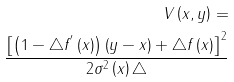<formula> <loc_0><loc_0><loc_500><loc_500>V \left ( x , y \right ) = \\ \frac { \left [ \left ( 1 - \triangle f ^ { ^ { \prime } } \left ( x \right ) \right ) \left ( y - x \right ) + \triangle f \left ( x \right ) \right ] ^ { 2 } } { 2 \sigma ^ { 2 } \left ( x \right ) \triangle }</formula> 